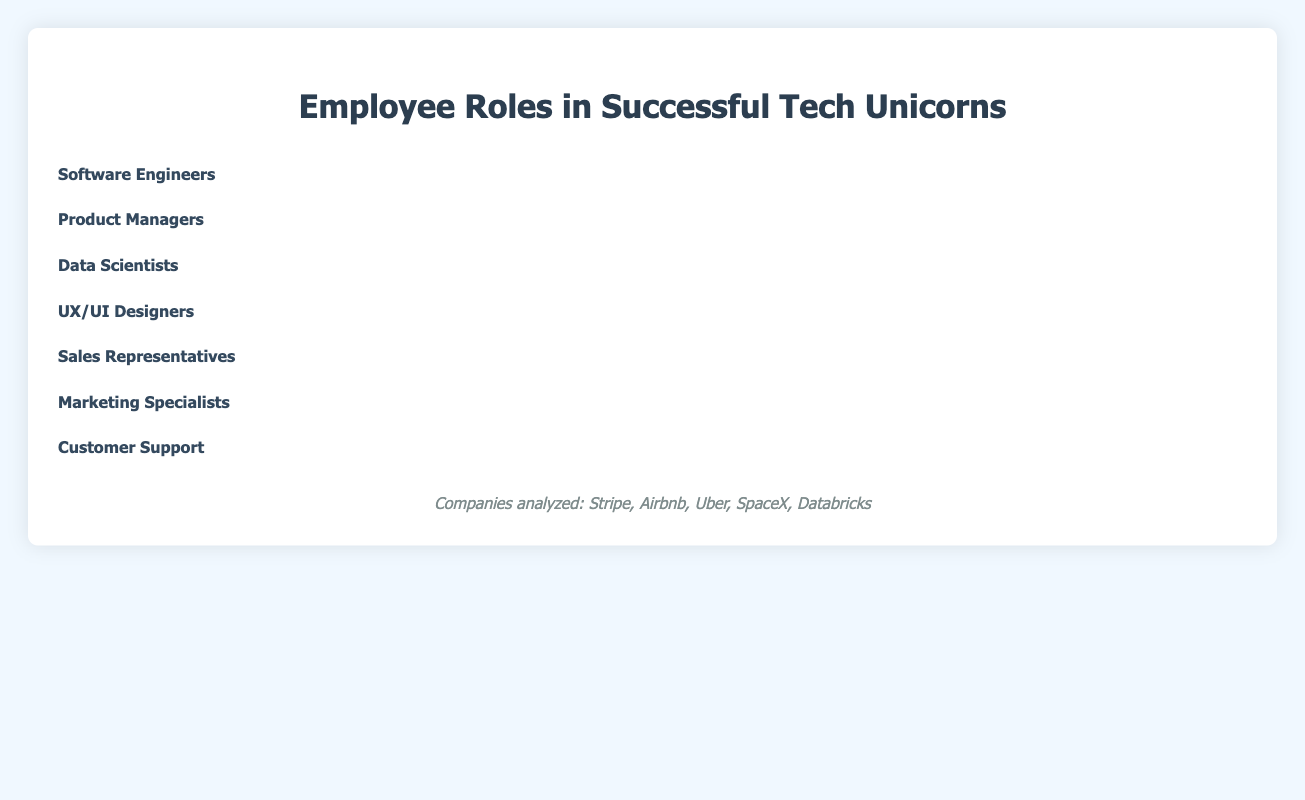Which role has the highest count of employees? By looking at the number of icons for each role in the isotype plot, the role with the most icons represents the highest count of employees. Software Engineers have the most icons with 5 groups of 10 laptops, indicating they have the highest count of employees.
Answer: Software Engineers How many more Data Scientists are there compared to UX/UI Designers? Count the icons for Data Scientists and UX/UI Designers, then calculate the difference. Data Scientists have 2 groups of 10 icons (20) and UX/UI Designers have 1 group of 10 icons (10). So, 20 - 10 = 10 more Data Scientists.
Answer: 10 What is the total number of employees in Sales Representatives and Marketing Specialists combined? Count the number of icons for Sales Representatives and Marketing Specialists and sum them up. Sales Representatives have 3 groups of 10 icons (30) and Marketing Specialists have 1 group of 10 icons with 2 extra icons (12). So, 30 + 12 = 42.
Answer: 42 Which role has the fewest number of employees? Identify the role with the least number of icons. UX/UI Designers have the fewest icons with only 1 group of 10 icons.
Answer: UX/UI Designers Are there more Customer Support employees or Product Managers? Compare the number of icons for Customer Support and Product Managers. Customer Support has 2 groups of 10 icons with 8 extra icons (18) while Product Managers have 1 group of 10 icons with 5 extra icons (15). Thus, there are more Customer Support employees.
Answer: Customer Support What percentage of the total employees do Software Engineers represent? Sum the total employees in all roles and then calculate the percentage for Software Engineers. Total employees count = 50 (Software Engineers) + 15 (Product Managers) + 20 (Data Scientists) + 10 (UX/UI Designers) + 25 (Sales Representatives) + 12 (Marketing Specialists) + 18 (Customer Support) = 150. Percentage = (50 / 150) * 100 = 33.33%.
Answer: 33.33% Which two roles together make up more than 50% of the total employees? Identify the roles with higher counts and sum them up to check if they exceed 50% of the total employees (which is 75). Software Engineers have 50, and adding Sales Representatives with 25 makes 75, which is exactly 50%. Considering another pair, Software Engineers and Data Scientists give 50 + 20 = 70, which is less than 75. Only Software Engineers and Sales Representatives together make 50%.
Answer: Software Engineers and Sales Representatives How does the count of Product Managers compare to that of Marketing Specialists? Count the icons for Product Managers and Marketing Specialists and then compare them. Product Managers have 15 icons and Marketing Specialists have 12 icons. Thus, Product Managers are more than Marketing Specialists.
Answer: Product Managers What is the combined count of UX/UI Designers and Data Scientists? Add the number of icons for UX/UI Designers and Data Scientists. UX/UI Designers have 10 and Data Scientists have 20. So, 10 + 20 = 30.
Answer: 30 